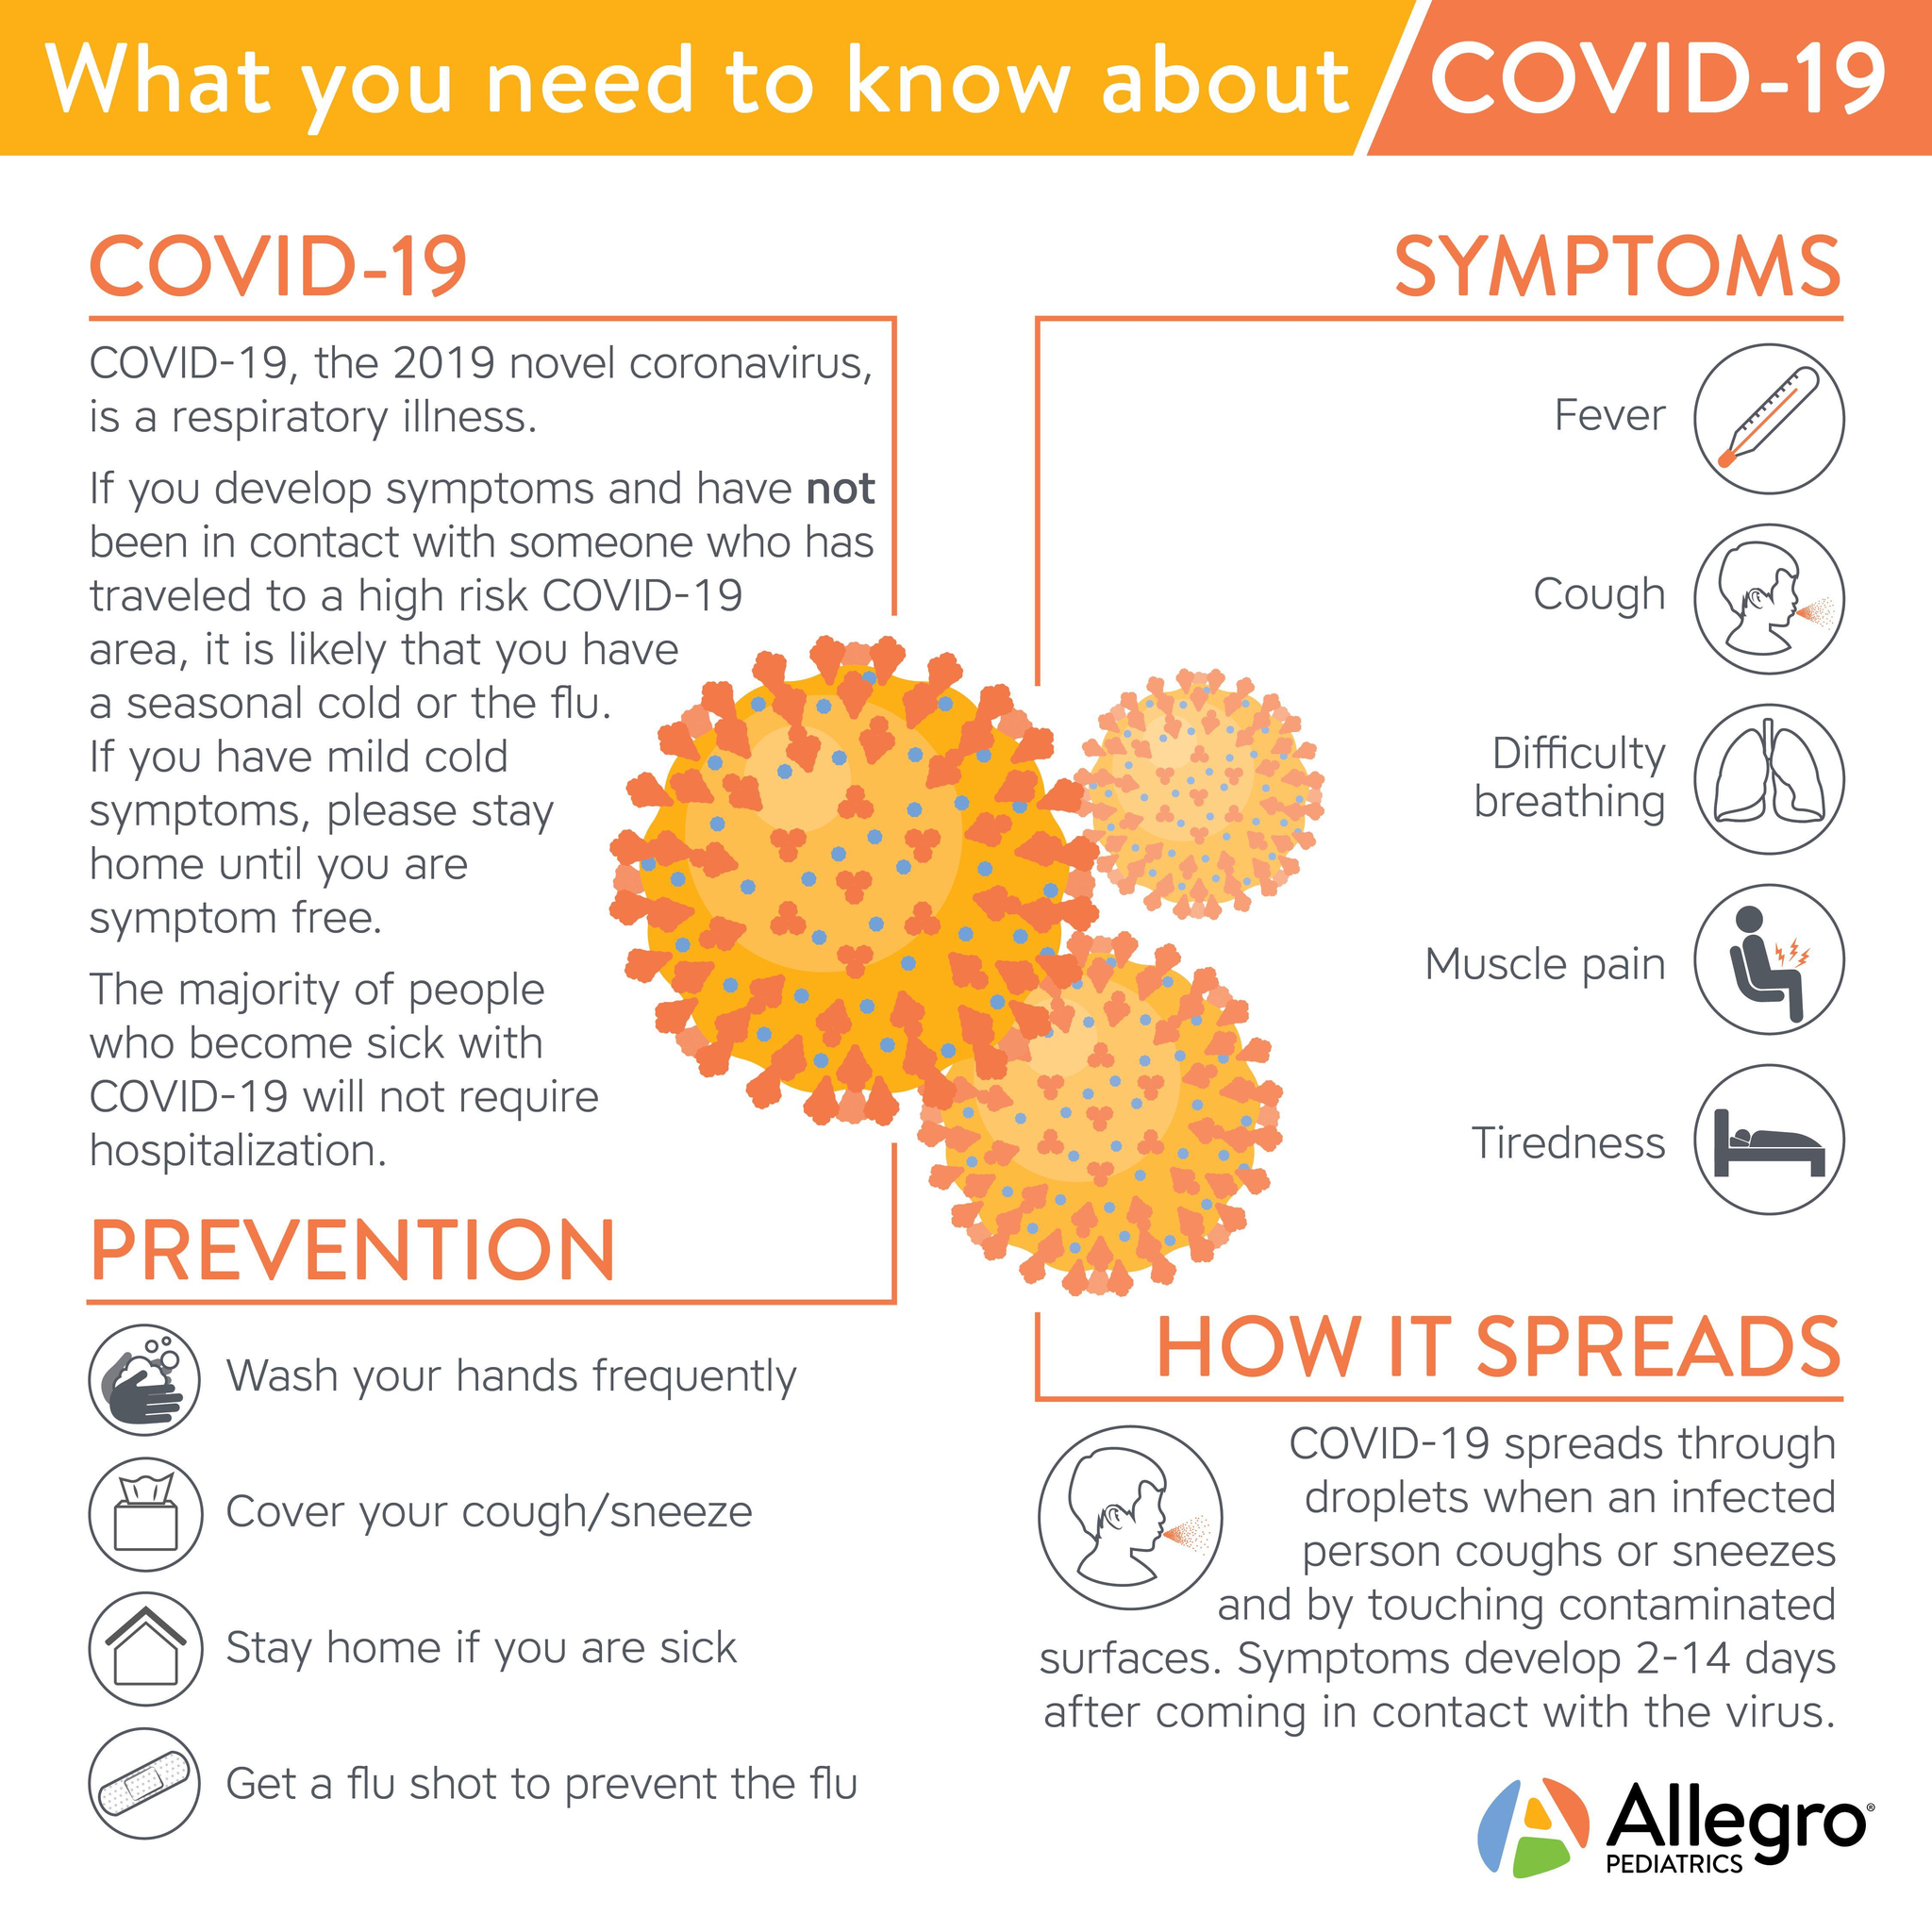List the first three symptoms of COVID-19.
Answer the question with a short phrase. Fever, Cough, Difficulty breathing 